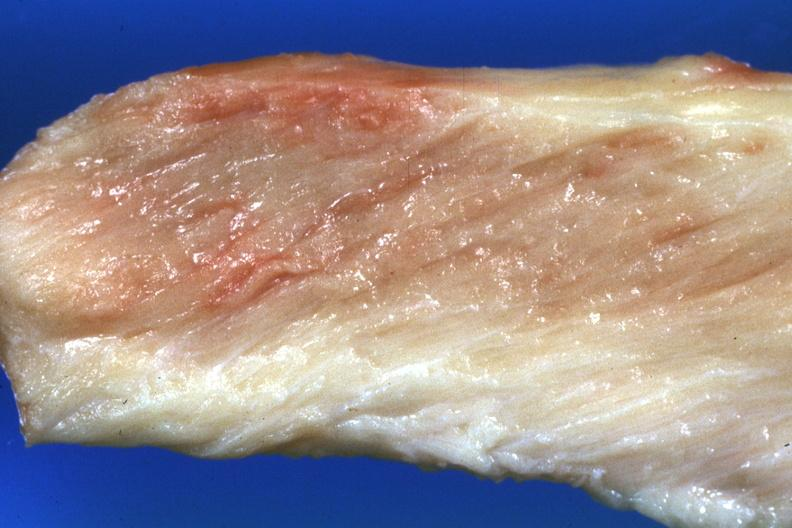what does this image show?
Answer the question using a single word or phrase. Close-up view pale muscle 